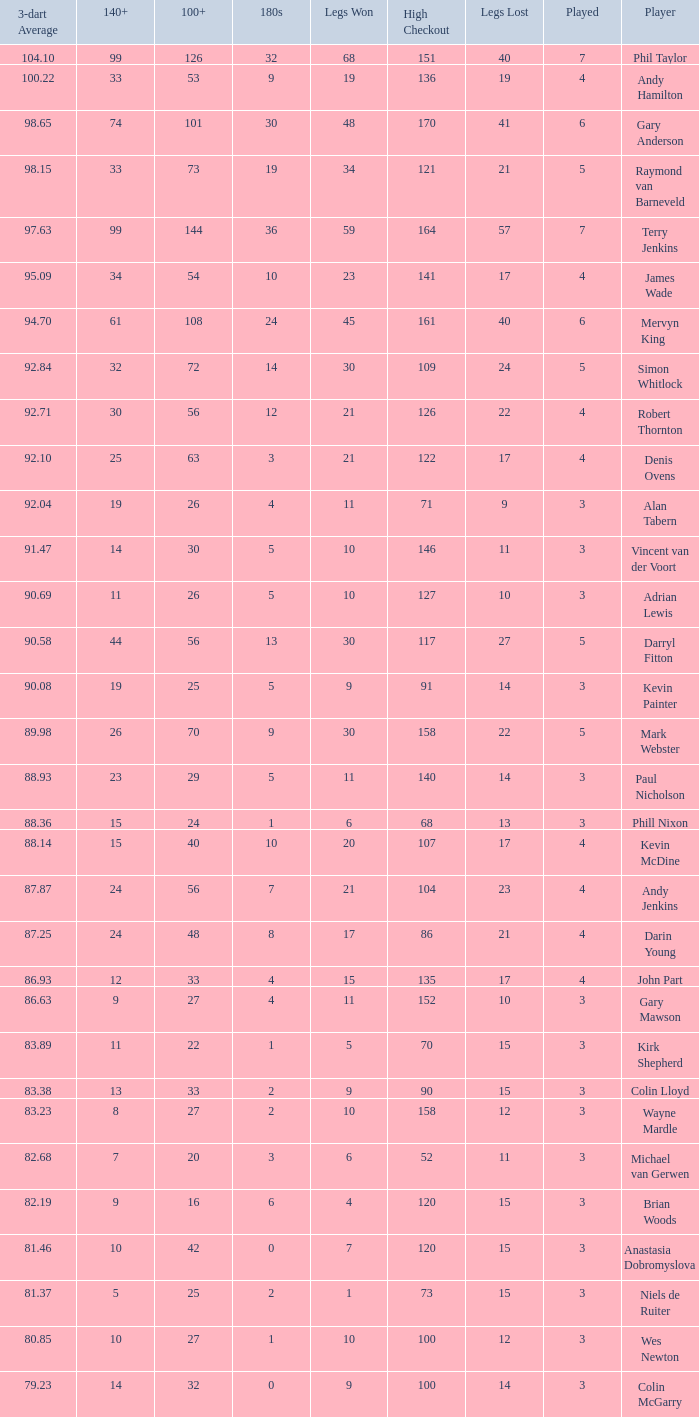Parse the table in full. {'header': ['3-dart Average', '140+', '100+', '180s', 'Legs Won', 'High Checkout', 'Legs Lost', 'Played', 'Player'], 'rows': [['104.10', '99', '126', '32', '68', '151', '40', '7', 'Phil Taylor'], ['100.22', '33', '53', '9', '19', '136', '19', '4', 'Andy Hamilton'], ['98.65', '74', '101', '30', '48', '170', '41', '6', 'Gary Anderson'], ['98.15', '33', '73', '19', '34', '121', '21', '5', 'Raymond van Barneveld'], ['97.63', '99', '144', '36', '59', '164', '57', '7', 'Terry Jenkins'], ['95.09', '34', '54', '10', '23', '141', '17', '4', 'James Wade'], ['94.70', '61', '108', '24', '45', '161', '40', '6', 'Mervyn King'], ['92.84', '32', '72', '14', '30', '109', '24', '5', 'Simon Whitlock'], ['92.71', '30', '56', '12', '21', '126', '22', '4', 'Robert Thornton'], ['92.10', '25', '63', '3', '21', '122', '17', '4', 'Denis Ovens'], ['92.04', '19', '26', '4', '11', '71', '9', '3', 'Alan Tabern'], ['91.47', '14', '30', '5', '10', '146', '11', '3', 'Vincent van der Voort'], ['90.69', '11', '26', '5', '10', '127', '10', '3', 'Adrian Lewis'], ['90.58', '44', '56', '13', '30', '117', '27', '5', 'Darryl Fitton'], ['90.08', '19', '25', '5', '9', '91', '14', '3', 'Kevin Painter'], ['89.98', '26', '70', '9', '30', '158', '22', '5', 'Mark Webster'], ['88.93', '23', '29', '5', '11', '140', '14', '3', 'Paul Nicholson'], ['88.36', '15', '24', '1', '6', '68', '13', '3', 'Phill Nixon'], ['88.14', '15', '40', '10', '20', '107', '17', '4', 'Kevin McDine'], ['87.87', '24', '56', '7', '21', '104', '23', '4', 'Andy Jenkins'], ['87.25', '24', '48', '8', '17', '86', '21', '4', 'Darin Young'], ['86.93', '12', '33', '4', '15', '135', '17', '4', 'John Part'], ['86.63', '9', '27', '4', '11', '152', '10', '3', 'Gary Mawson'], ['83.89', '11', '22', '1', '5', '70', '15', '3', 'Kirk Shepherd'], ['83.38', '13', '33', '2', '9', '90', '15', '3', 'Colin Lloyd'], ['83.23', '8', '27', '2', '10', '158', '12', '3', 'Wayne Mardle'], ['82.68', '7', '20', '3', '6', '52', '11', '3', 'Michael van Gerwen'], ['82.19', '9', '16', '6', '4', '120', '15', '3', 'Brian Woods'], ['81.46', '10', '42', '0', '7', '120', '15', '3', 'Anastasia Dobromyslova'], ['81.37', '5', '25', '2', '1', '73', '15', '3', 'Niels de Ruiter'], ['80.85', '10', '27', '1', '10', '100', '12', '3', 'Wes Newton'], ['79.23', '14', '32', '0', '9', '100', '14', '3', 'Colin McGarry']]} What is the high checkout when Legs Won is smaller than 9, a 180s of 1, and a 3-dart Average larger than 88.36? None. 